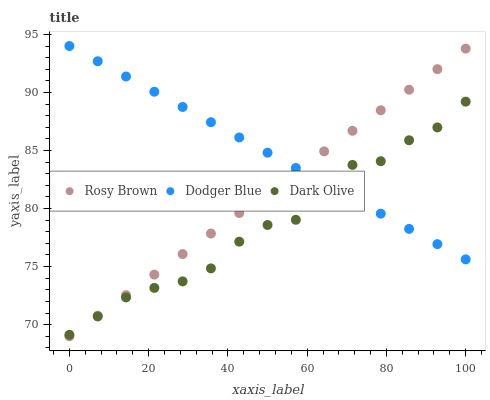Does Dark Olive have the minimum area under the curve?
Answer yes or no. Yes. Does Dodger Blue have the maximum area under the curve?
Answer yes or no. Yes. Does Rosy Brown have the minimum area under the curve?
Answer yes or no. No. Does Rosy Brown have the maximum area under the curve?
Answer yes or no. No. Is Dodger Blue the smoothest?
Answer yes or no. Yes. Is Dark Olive the roughest?
Answer yes or no. Yes. Is Rosy Brown the smoothest?
Answer yes or no. No. Is Rosy Brown the roughest?
Answer yes or no. No. Does Rosy Brown have the lowest value?
Answer yes or no. Yes. Does Dodger Blue have the lowest value?
Answer yes or no. No. Does Dodger Blue have the highest value?
Answer yes or no. Yes. Does Rosy Brown have the highest value?
Answer yes or no. No. Does Dark Olive intersect Dodger Blue?
Answer yes or no. Yes. Is Dark Olive less than Dodger Blue?
Answer yes or no. No. Is Dark Olive greater than Dodger Blue?
Answer yes or no. No. 